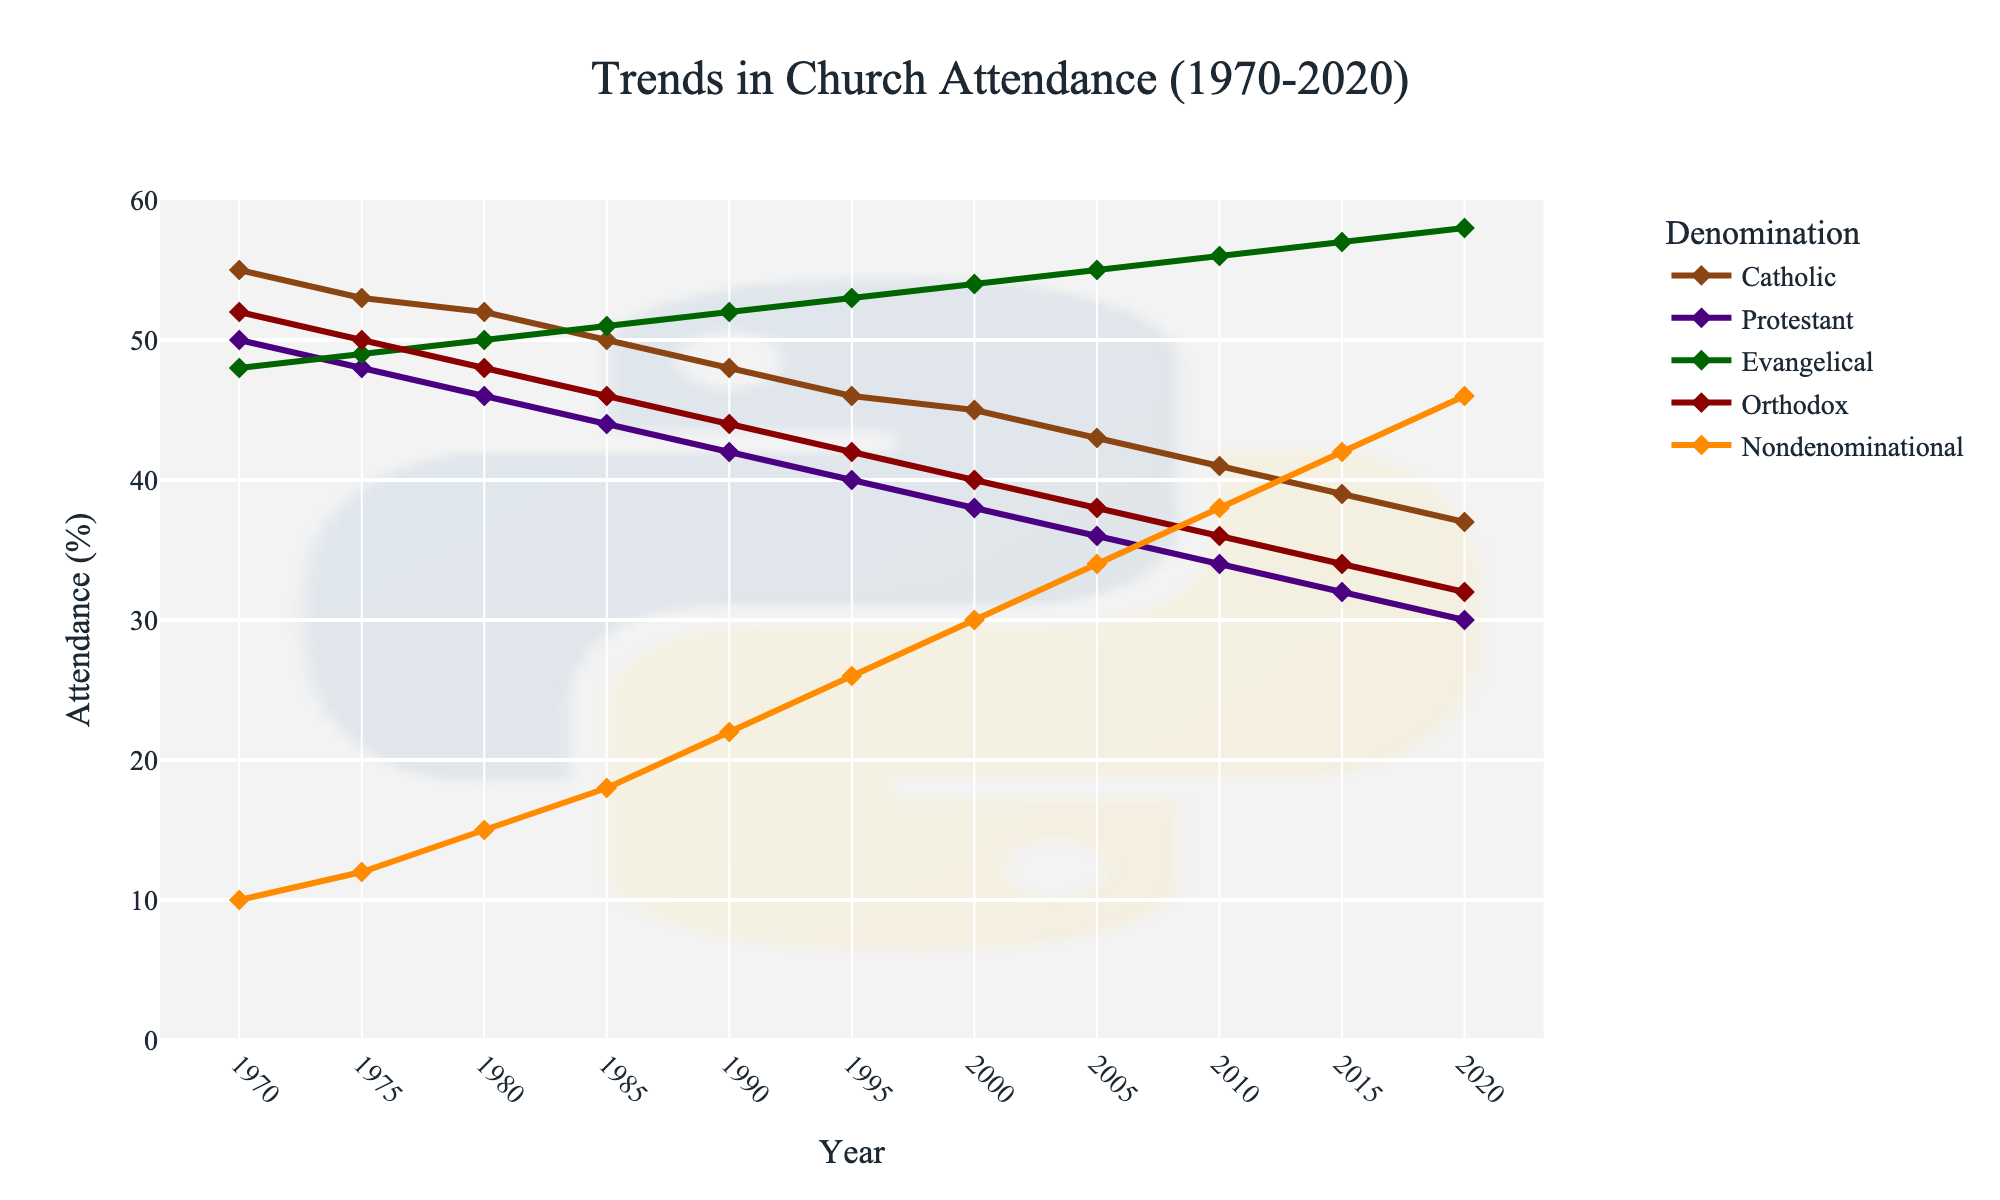Which denomination had the highest attendance in 2020? To find the highest attendance in 2020, locate the data point corresponding to the year 2020 on the x-axis. Compare the y-values for Catholic, Protestant, Evangelical, Orthodox, and Nondenominational denominations.
Answer: Evangelical By how much did the attendance for Catholics decrease from 1970 to 2020? To determine the decrease, identify the attendance percentage for Catholics in 1970 and 2020. Subtract the 2020 value from the 1970 value (55% - 37%).
Answer: 18% What is the average attendance for the Protestant denomination across the entire timeline? Compute the sum of the Protestant attendance percentages over the years (50 + 48 + 46 + 44 + 42 + 40 + 38 + 36 + 34 + 32 + 30) and divide by the number of data points (11).
Answer: 64 / 11 ≈ 40.2% Which denomination shows a continuous increase in attendance throughout the years? Identify the line that consistently rises from 1970 to 2020 on the chart. Compare the slopes of the lines for all denominations.
Answer: Nondenominational In which year did Evangelical attendance surpass Catholic attendance? Check the intersections of the Evangelical and Catholic lines on the graph to see when the Evangelical line is higher than the Catholic line. The key point occurs when Evangelical attendance (in 1995, 53%) exceeds Catholic attendance (46%).
Answer: 1995 What is the difference in attendance between Orthodox and Nondenominational denominations in 2010? Find the attendance percentages for Orthodox and Nondenominational in 2010 (36% - 38%). Subtract the Orthodox percentage from the Nondenominational percentage.
Answer: 2% Which denomination's attendance had the smallest change between 1970 to 2020? Calculate the difference between the 1970 and 2020 attendance values for each denomination. The denomination with the smallest value indicates the smallest change.
Answer: Orthodox (52% - 32%) = 20% Compare the trend of Protestant and Evangelical attendances between 1970 and 2020. How do their trends differ? Analyze the line plots for both denominations. Protestants show a consistent decline from 50% to 30%, while Evangelicals show a steady increase from 48% to 58%.
Answer: Protestant decreased, Evangelical increased In which year did the Catholic attendance decline to 50%? Locate the year on the x-axis when the Catholic line intersects the 50% mark on the y-axis. By visual inspection, this is approximately in 1985.
Answer: 1985 How did the attendance for the Orthodox denomination change between 1990 and 2015? Identify the attendance percentages for Orthodox in 1990 and 2015 (44% and 34%). Subtract the 2015 value from the 1990 value to find the change.
Answer: 10% decrease 